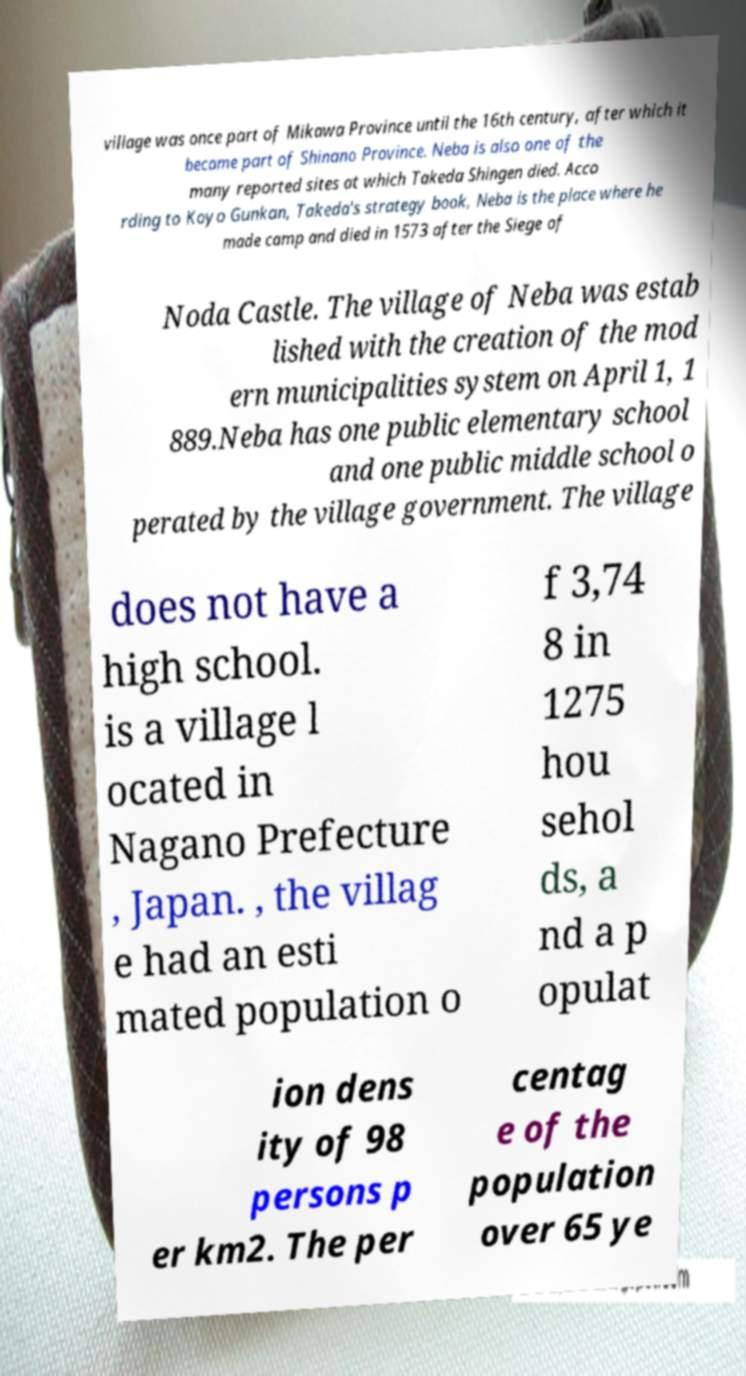I need the written content from this picture converted into text. Can you do that? village was once part of Mikawa Province until the 16th century, after which it became part of Shinano Province. Neba is also one of the many reported sites at which Takeda Shingen died. Acco rding to Koyo Gunkan, Takeda's strategy book, Neba is the place where he made camp and died in 1573 after the Siege of Noda Castle. The village of Neba was estab lished with the creation of the mod ern municipalities system on April 1, 1 889.Neba has one public elementary school and one public middle school o perated by the village government. The village does not have a high school. is a village l ocated in Nagano Prefecture , Japan. , the villag e had an esti mated population o f 3,74 8 in 1275 hou sehol ds, a nd a p opulat ion dens ity of 98 persons p er km2. The per centag e of the population over 65 ye 